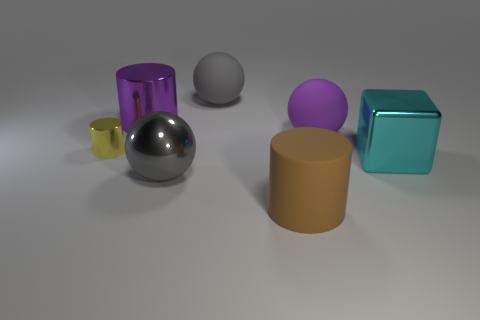How many objects are shiny cylinders or large metal blocks? In the image, there are two objects that can be identified as shiny cylinders – one is purple and the other is silver. Although there are other cylindrical and cube-shaped objects, they are not particularly shiny or metallic. Therefore, there are two objects that fit the description of being shiny cylinders. 